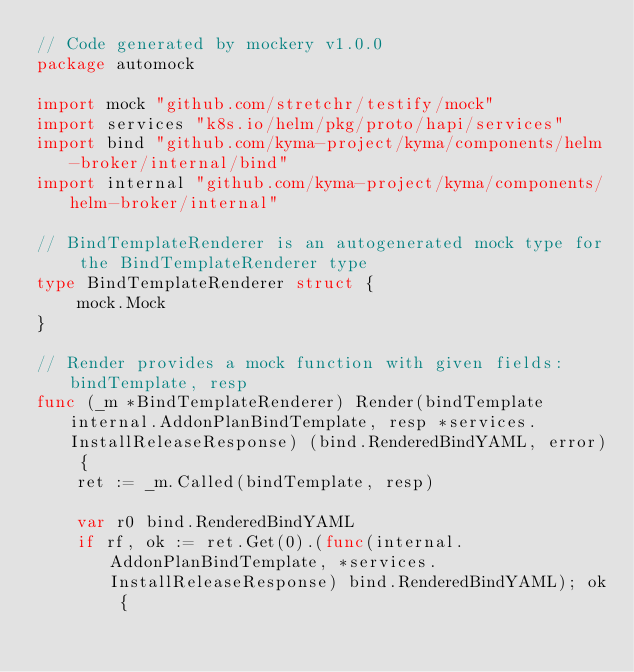<code> <loc_0><loc_0><loc_500><loc_500><_Go_>// Code generated by mockery v1.0.0
package automock

import mock "github.com/stretchr/testify/mock"
import services "k8s.io/helm/pkg/proto/hapi/services"
import bind "github.com/kyma-project/kyma/components/helm-broker/internal/bind"
import internal "github.com/kyma-project/kyma/components/helm-broker/internal"

// BindTemplateRenderer is an autogenerated mock type for the BindTemplateRenderer type
type BindTemplateRenderer struct {
	mock.Mock
}

// Render provides a mock function with given fields: bindTemplate, resp
func (_m *BindTemplateRenderer) Render(bindTemplate internal.AddonPlanBindTemplate, resp *services.InstallReleaseResponse) (bind.RenderedBindYAML, error) {
	ret := _m.Called(bindTemplate, resp)

	var r0 bind.RenderedBindYAML
	if rf, ok := ret.Get(0).(func(internal.AddonPlanBindTemplate, *services.InstallReleaseResponse) bind.RenderedBindYAML); ok {</code> 